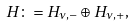<formula> <loc_0><loc_0><loc_500><loc_500>H \colon = H _ { \nu , - } \oplus H _ { \nu , + } ,</formula> 